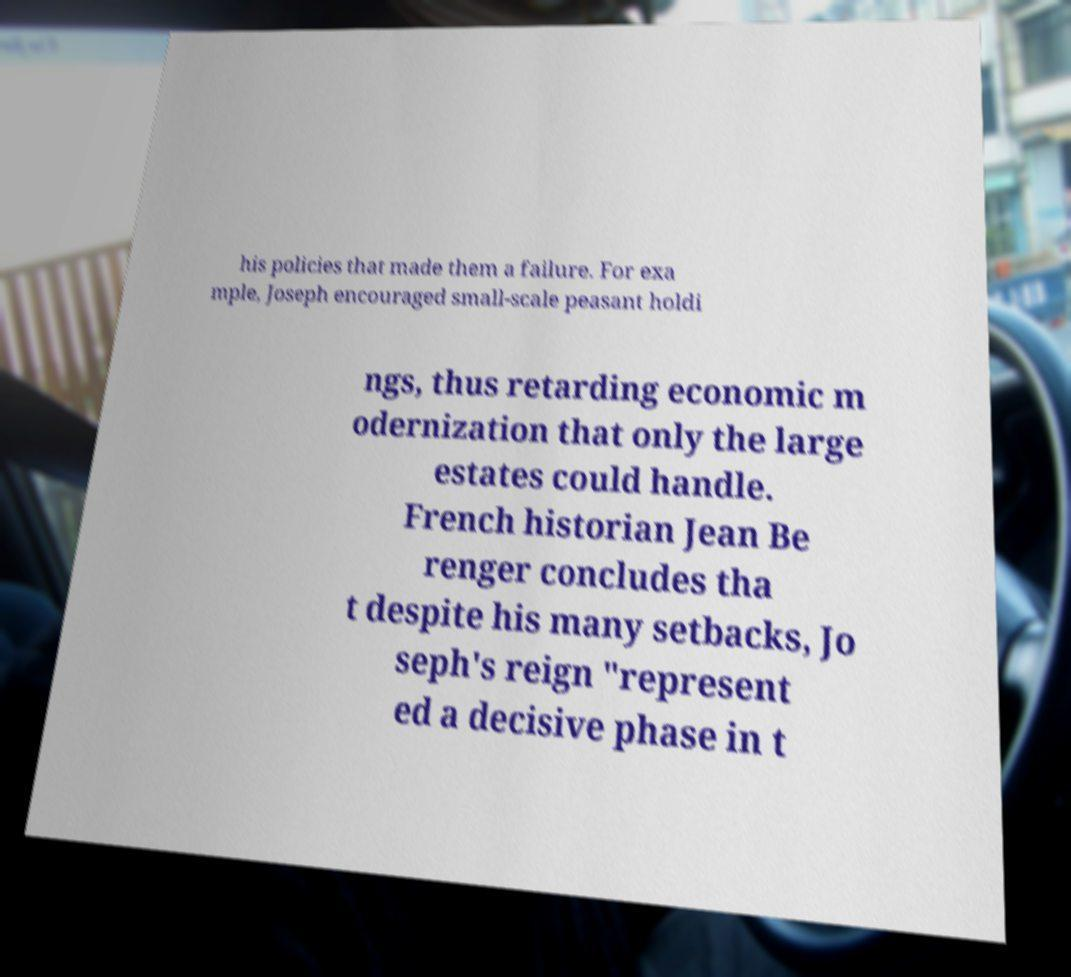There's text embedded in this image that I need extracted. Can you transcribe it verbatim? his policies that made them a failure. For exa mple, Joseph encouraged small-scale peasant holdi ngs, thus retarding economic m odernization that only the large estates could handle. French historian Jean Be renger concludes tha t despite his many setbacks, Jo seph's reign "represent ed a decisive phase in t 